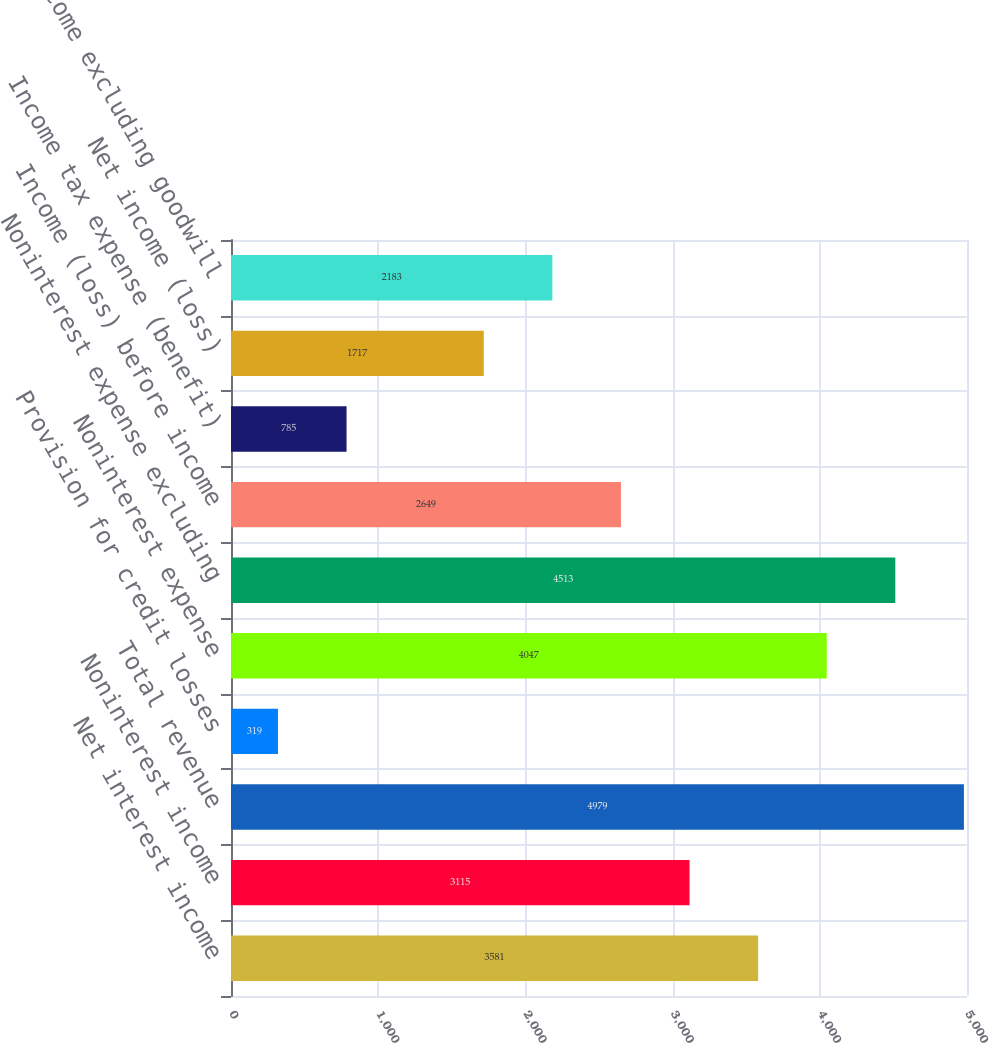<chart> <loc_0><loc_0><loc_500><loc_500><bar_chart><fcel>Net interest income<fcel>Noninterest income<fcel>Total revenue<fcel>Provision for credit losses<fcel>Noninterest expense<fcel>Noninterest expense excluding<fcel>Income (loss) before income<fcel>Income tax expense (benefit)<fcel>Net income (loss)<fcel>Net income excluding goodwill<nl><fcel>3581<fcel>3115<fcel>4979<fcel>319<fcel>4047<fcel>4513<fcel>2649<fcel>785<fcel>1717<fcel>2183<nl></chart> 